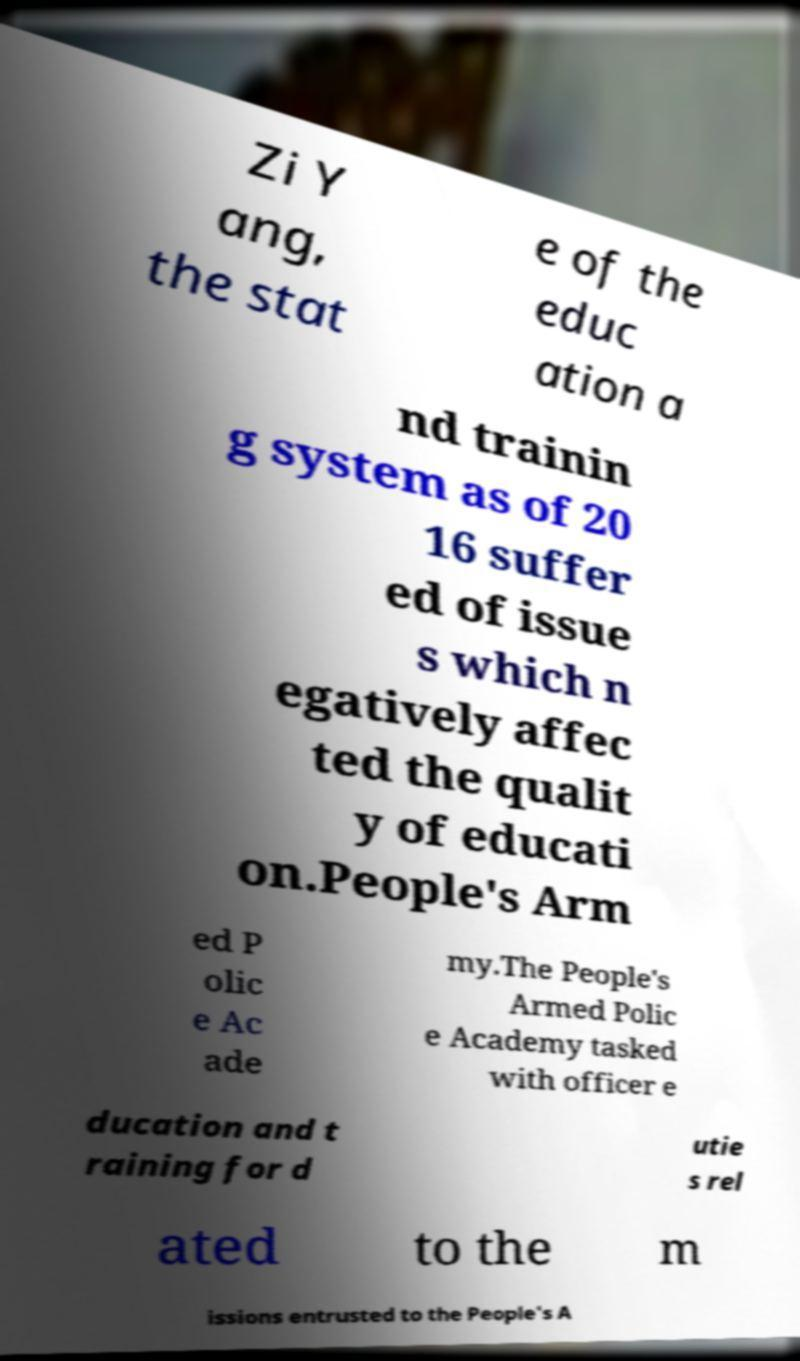There's text embedded in this image that I need extracted. Can you transcribe it verbatim? Zi Y ang, the stat e of the educ ation a nd trainin g system as of 20 16 suffer ed of issue s which n egatively affec ted the qualit y of educati on.People's Arm ed P olic e Ac ade my.The People's Armed Polic e Academy tasked with officer e ducation and t raining for d utie s rel ated to the m issions entrusted to the People's A 